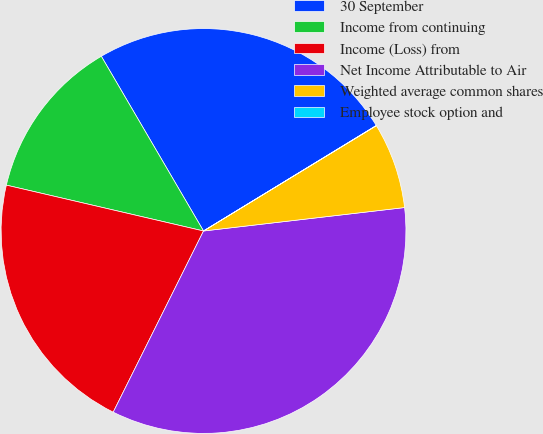Convert chart to OTSL. <chart><loc_0><loc_0><loc_500><loc_500><pie_chart><fcel>30 September<fcel>Income from continuing<fcel>Income (Loss) from<fcel>Net Income Attributable to Air<fcel>Weighted average common shares<fcel>Employee stock option and<nl><fcel>24.7%<fcel>12.94%<fcel>21.28%<fcel>34.21%<fcel>6.86%<fcel>0.02%<nl></chart> 